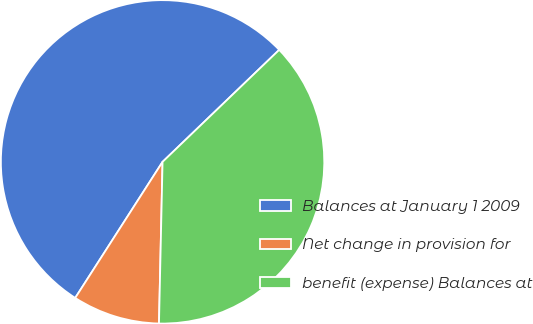Convert chart. <chart><loc_0><loc_0><loc_500><loc_500><pie_chart><fcel>Balances at January 1 2009<fcel>Net change in provision for<fcel>benefit (expense) Balances at<nl><fcel>53.74%<fcel>8.73%<fcel>37.53%<nl></chart> 